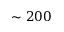<formula> <loc_0><loc_0><loc_500><loc_500>\sim 2 0 0</formula> 